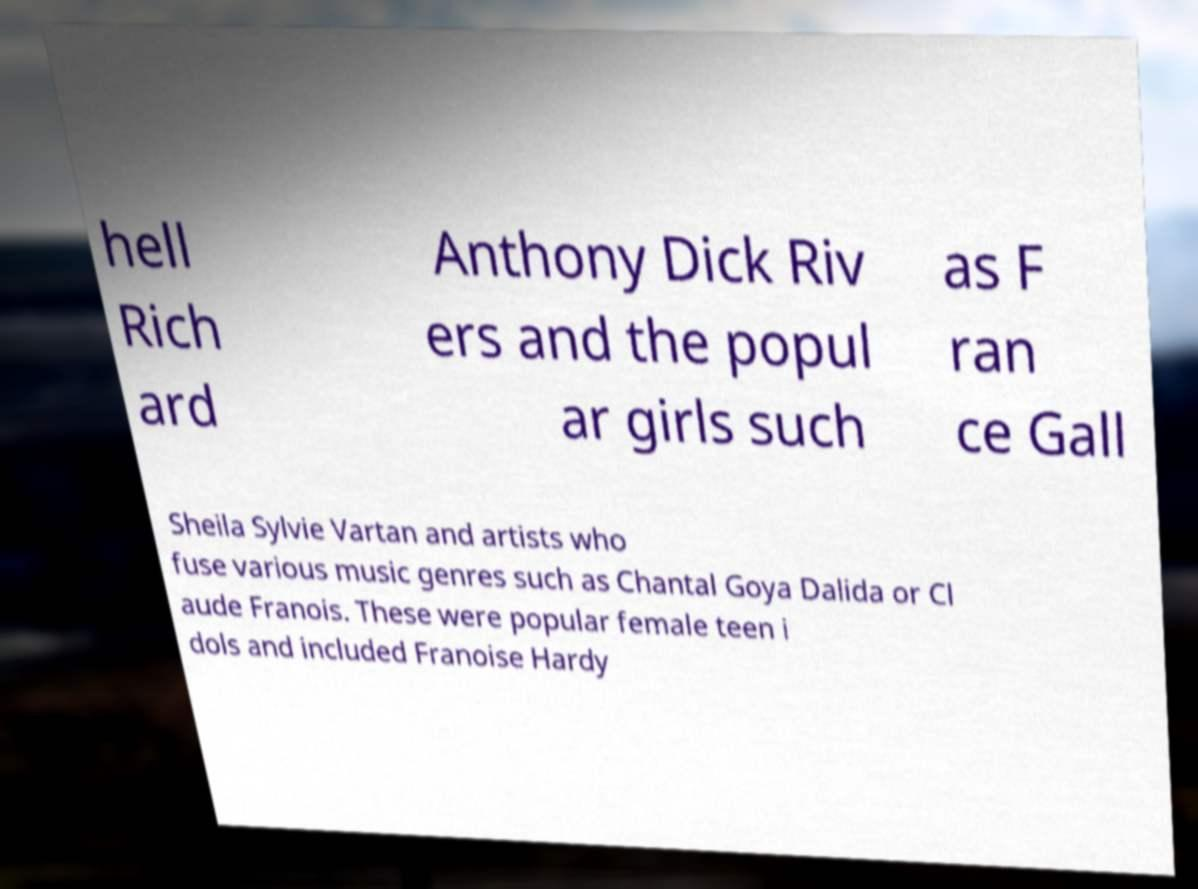Please read and relay the text visible in this image. What does it say? hell Rich ard Anthony Dick Riv ers and the popul ar girls such as F ran ce Gall Sheila Sylvie Vartan and artists who fuse various music genres such as Chantal Goya Dalida or Cl aude Franois. These were popular female teen i dols and included Franoise Hardy 